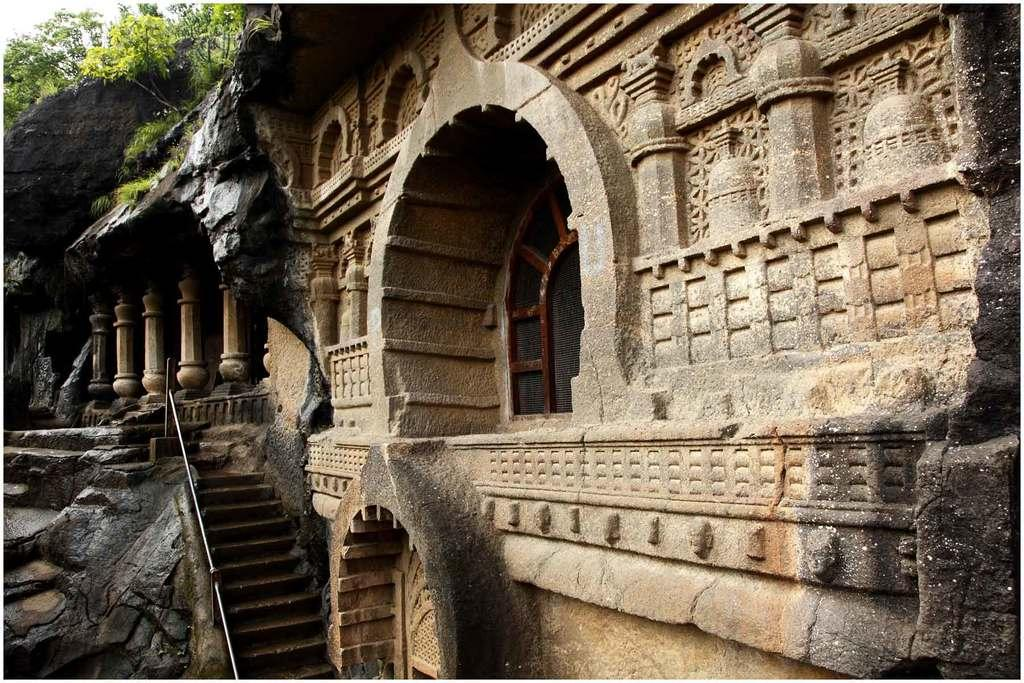What type of decoration can be seen on the wall in the image? There is carving on the wall in the image. What architectural features are present in the image? There are pillars, stairs, and rods in the image. What openings can be seen in the image? There are windows in the image. What natural elements are present in the image? There is a rock and trees in the image. What part of the sky is visible in the image? The sky is visible in the top left corner of the image. What type of riddle is written on the rock in the image? There is no riddle written on the rock in the image; it is a natural element. Can you see a cactus growing among the trees in the image? There is no cactus present in the image; only trees are visible. 